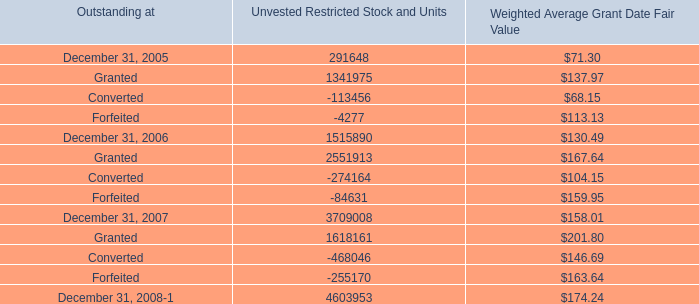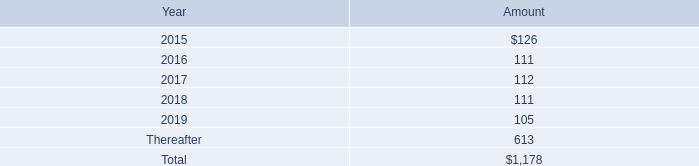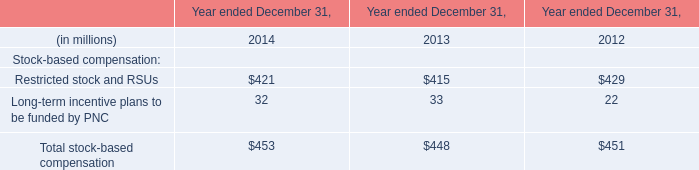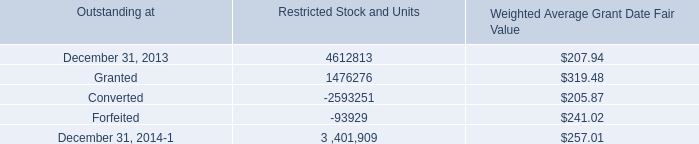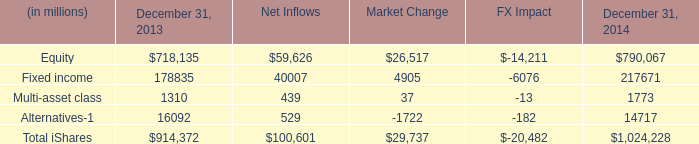If Equity develops with the same increasing rate in 2014, what will it reach in 2015? (in dollars in millions) 
Computations: (790067 * (1 + ((790067 - 718135) / 718135)))
Answer: 869204.06955. 